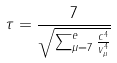Convert formula to latex. <formula><loc_0><loc_0><loc_500><loc_500>\tau = \frac { 7 } { \sqrt { \sum _ { \mu = 7 } ^ { e } \frac { c ^ { 4 } } { v _ { \mu } ^ { 4 } } } }</formula> 